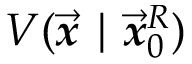<formula> <loc_0><loc_0><loc_500><loc_500>V ( \overrightarrow { \mathbf i t { x } } | \overrightarrow { \mathbf i t { x } } _ { 0 } ^ { R } )</formula> 